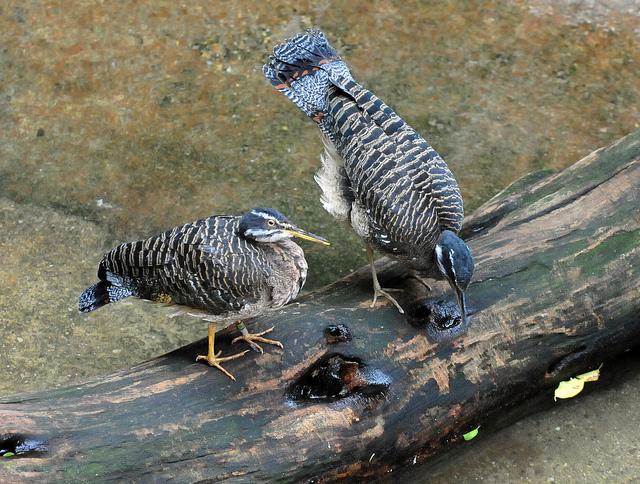What type of birds are these?
Concise answer only. Woodpeckers. What are the birds standing on?
Answer briefly. Log. Are both birds feet the same color?
Keep it brief. No. 